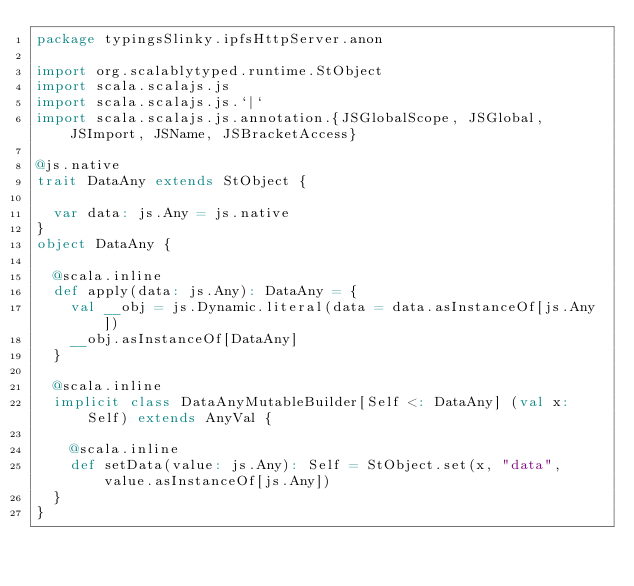Convert code to text. <code><loc_0><loc_0><loc_500><loc_500><_Scala_>package typingsSlinky.ipfsHttpServer.anon

import org.scalablytyped.runtime.StObject
import scala.scalajs.js
import scala.scalajs.js.`|`
import scala.scalajs.js.annotation.{JSGlobalScope, JSGlobal, JSImport, JSName, JSBracketAccess}

@js.native
trait DataAny extends StObject {
  
  var data: js.Any = js.native
}
object DataAny {
  
  @scala.inline
  def apply(data: js.Any): DataAny = {
    val __obj = js.Dynamic.literal(data = data.asInstanceOf[js.Any])
    __obj.asInstanceOf[DataAny]
  }
  
  @scala.inline
  implicit class DataAnyMutableBuilder[Self <: DataAny] (val x: Self) extends AnyVal {
    
    @scala.inline
    def setData(value: js.Any): Self = StObject.set(x, "data", value.asInstanceOf[js.Any])
  }
}
</code> 